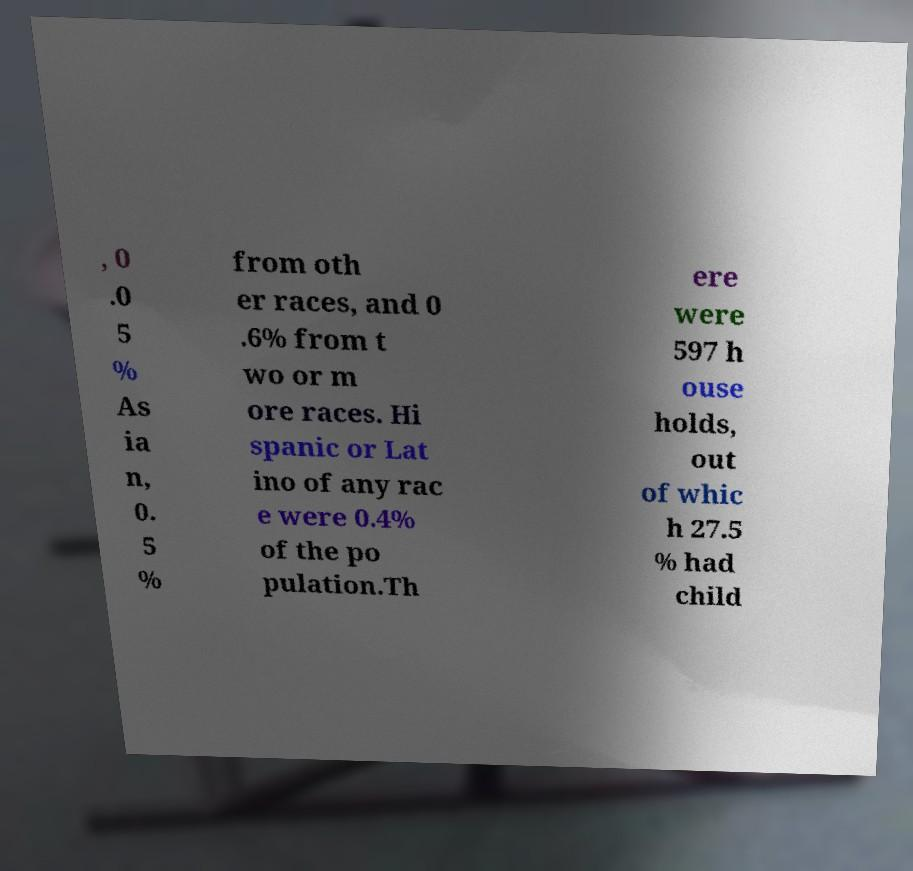What messages or text are displayed in this image? I need them in a readable, typed format. , 0 .0 5 % As ia n, 0. 5 % from oth er races, and 0 .6% from t wo or m ore races. Hi spanic or Lat ino of any rac e were 0.4% of the po pulation.Th ere were 597 h ouse holds, out of whic h 27.5 % had child 